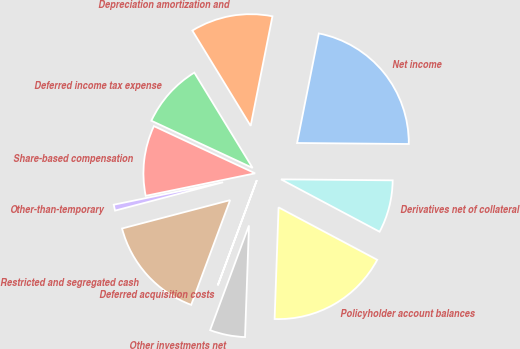<chart> <loc_0><loc_0><loc_500><loc_500><pie_chart><fcel>Net income<fcel>Depreciation amortization and<fcel>Deferred income tax expense<fcel>Share-based compensation<fcel>Other-than-temporary<fcel>Restricted and segregated cash<fcel>Deferred acquisition costs<fcel>Other investments net<fcel>Policyholder account balances<fcel>Derivatives net of collateral<nl><fcel>22.02%<fcel>11.86%<fcel>9.32%<fcel>10.17%<fcel>0.86%<fcel>15.25%<fcel>0.01%<fcel>5.09%<fcel>17.79%<fcel>7.63%<nl></chart> 